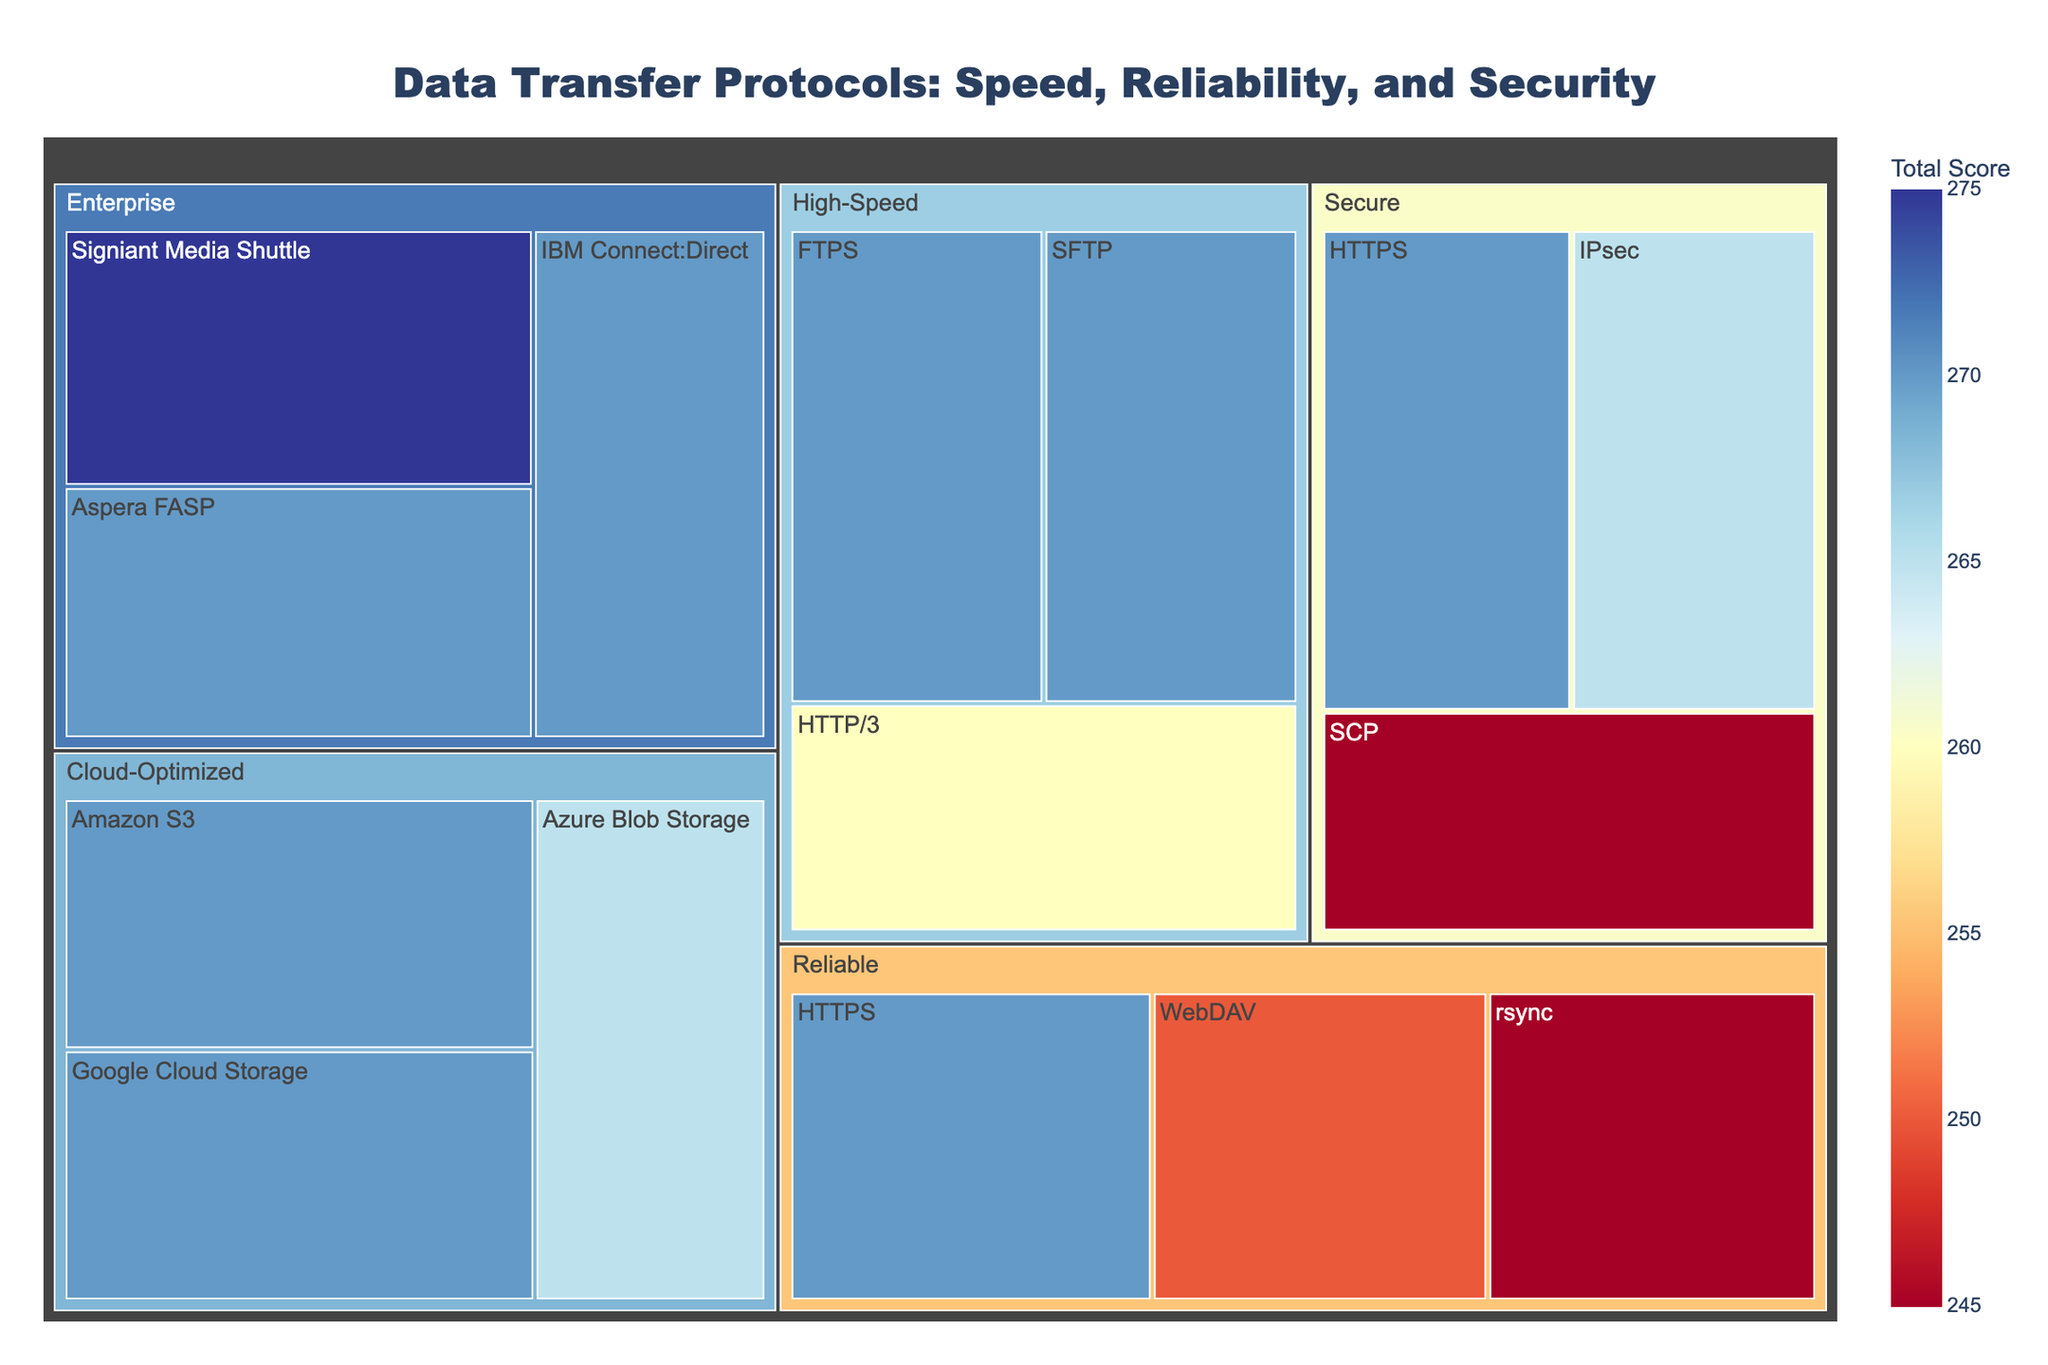what is the title of this treemap? The title of a graph is usually located at the top of the figure. In this case, the title is clear from the description of the plot.
Answer: Data Transfer Protocols: Speed, Reliability, and Security which category has the highest total score, and what is it? The treemap assigns a total score to each protocol by summing its Speed, Reliability, and Security scores. Then, by evaluating the categories visually or through the data, we can identify the one with the highest total score.
Answer: Enterprise, Aspera FASP, 270 which protocol within 'High-Speed' has the highest security score? To answer this, we need to look specifically at the protocols listed under the "High-Speed" category. Each of these protocols will have a score for Security. The one with the highest score can be identified by visually inspecting the treemap or referencing the data.
Answer: FTPS and SFTP, 95 what is the combined reliability score of the 'Reliable' category? To find this, sum the Reliability scores of all protocols under the "Reliable" category. The tree structure or the raw data can help us find these scores: HTTPS (95), WebDAV (90), and rsync (95). Adding these together gives us the total.
Answer: 280 compare the total score of SCP and Google Cloud Storage. Which one is higher, and by how much? Calculate the Total Score for both SCP and Google Cloud Storage by summing their Speed, Reliability, and Security scores. SCP has a total of 245 (65 + 85 + 95) and Google Cloud Storage has 270 (85 + 95 + 90). Subtract these to find the difference.
Answer: Google Cloud Storage is higher by 25 which protocol under 'Cloud-Optimized' category has the lowest speed score, and what is it? Look at the protocols under "Cloud-Optimized" in the treemap or in the data. Compare the Speed scores to identify the lowest one.
Answer: Azure Blob Storage, 80 is there any protocol that appears in more than one category? If yes, which protocol and which categories? Check the protocols listed under each category and look for any repeated names.
Answer: HTTPS, appears in both Reliable and Secure how does the total score of 'Amazon S3' compared to 'IBM Connect:Direct'? First, find the total scores of both protocols by summing their respective Speed, Reliability, and Security scores. Amazon S3 has 270 (85 + 95 + 90) and IBM Connect:Direct has 270 (85 + 95 + 90).
Answer: They are equal what is the average security score across all protocols? Add up all the Security scores from the protocols listed and divide by the total number of protocols. The sum is 1460 from 15 protocols. The average is calculated as 1460/15.
Answer: 97 which category has the most protocols listed? Count the number of protocols listed under each category by referring to the treemap or data. The category with the highest count is the one with the most protocols.
Answer: Secure and Cloud-Optimized, both have 3 protocols 